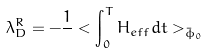<formula> <loc_0><loc_0><loc_500><loc_500>\lambda _ { D } ^ { R } = - \frac { 1 } { } < \int _ { 0 } ^ { T } H _ { e f f } d t > _ { \bar { \phi } _ { 0 } }</formula> 